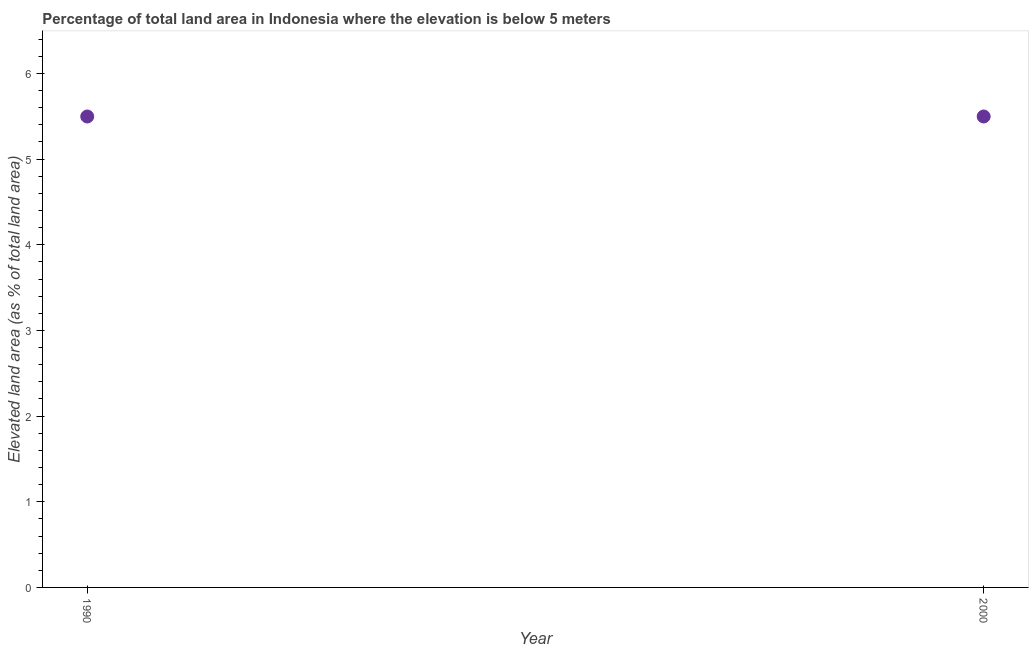What is the total elevated land area in 2000?
Keep it short and to the point. 5.5. Across all years, what is the maximum total elevated land area?
Your answer should be compact. 5.5. Across all years, what is the minimum total elevated land area?
Provide a short and direct response. 5.5. In which year was the total elevated land area minimum?
Your response must be concise. 1990. What is the sum of the total elevated land area?
Make the answer very short. 11. What is the difference between the total elevated land area in 1990 and 2000?
Provide a succinct answer. 0. What is the average total elevated land area per year?
Provide a short and direct response. 5.5. What is the median total elevated land area?
Offer a very short reply. 5.5. In how many years, is the total elevated land area greater than 0.6000000000000001 %?
Keep it short and to the point. 2. Does the total elevated land area monotonically increase over the years?
Your answer should be very brief. No. How many years are there in the graph?
Give a very brief answer. 2. Does the graph contain any zero values?
Offer a terse response. No. What is the title of the graph?
Keep it short and to the point. Percentage of total land area in Indonesia where the elevation is below 5 meters. What is the label or title of the X-axis?
Your answer should be very brief. Year. What is the label or title of the Y-axis?
Provide a succinct answer. Elevated land area (as % of total land area). What is the Elevated land area (as % of total land area) in 1990?
Offer a very short reply. 5.5. What is the Elevated land area (as % of total land area) in 2000?
Your response must be concise. 5.5. What is the difference between the Elevated land area (as % of total land area) in 1990 and 2000?
Provide a short and direct response. 0. 